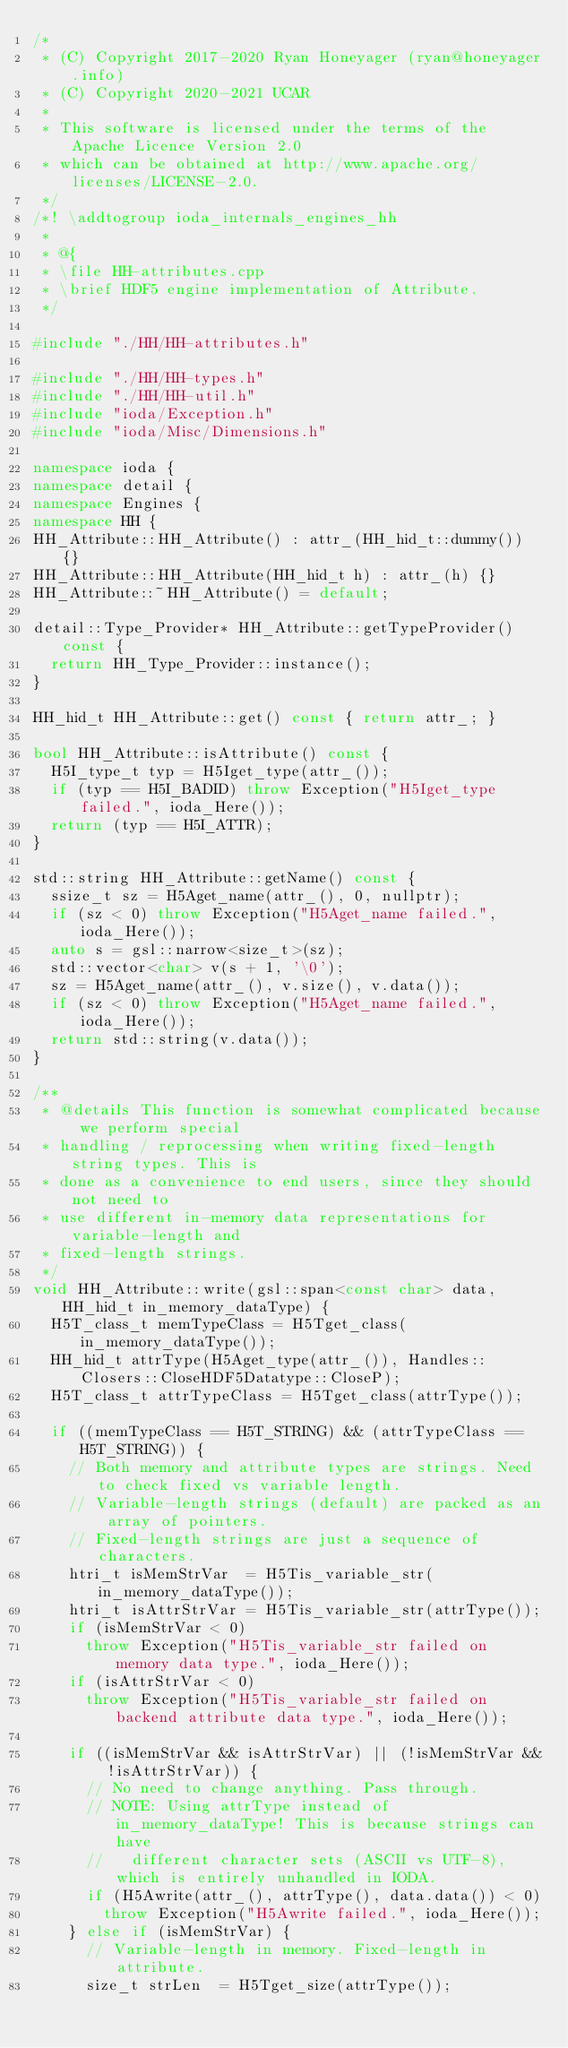<code> <loc_0><loc_0><loc_500><loc_500><_C++_>/*
 * (C) Copyright 2017-2020 Ryan Honeyager (ryan@honeyager.info)
 * (C) Copyright 2020-2021 UCAR
 *
 * This software is licensed under the terms of the Apache Licence Version 2.0
 * which can be obtained at http://www.apache.org/licenses/LICENSE-2.0.
 */
/*! \addtogroup ioda_internals_engines_hh
 *
 * @{
 * \file HH-attributes.cpp
 * \brief HDF5 engine implementation of Attribute.
 */

#include "./HH/HH-attributes.h"

#include "./HH/HH-types.h"
#include "./HH/HH-util.h"
#include "ioda/Exception.h"
#include "ioda/Misc/Dimensions.h"

namespace ioda {
namespace detail {
namespace Engines {
namespace HH {
HH_Attribute::HH_Attribute() : attr_(HH_hid_t::dummy()) {}
HH_Attribute::HH_Attribute(HH_hid_t h) : attr_(h) {}
HH_Attribute::~HH_Attribute() = default;

detail::Type_Provider* HH_Attribute::getTypeProvider() const {
  return HH_Type_Provider::instance();
}

HH_hid_t HH_Attribute::get() const { return attr_; }

bool HH_Attribute::isAttribute() const {
  H5I_type_t typ = H5Iget_type(attr_());
  if (typ == H5I_BADID) throw Exception("H5Iget_type failed.", ioda_Here());
  return (typ == H5I_ATTR);
}

std::string HH_Attribute::getName() const {
  ssize_t sz = H5Aget_name(attr_(), 0, nullptr);
  if (sz < 0) throw Exception("H5Aget_name failed.", ioda_Here());
  auto s = gsl::narrow<size_t>(sz);
  std::vector<char> v(s + 1, '\0');
  sz = H5Aget_name(attr_(), v.size(), v.data());
  if (sz < 0) throw Exception("H5Aget_name failed.", ioda_Here());
  return std::string(v.data());
}

/**
 * @details This function is somewhat complicated because we perform special
 * handling / reprocessing when writing fixed-length string types. This is
 * done as a convenience to end users, since they should not need to
 * use different in-memory data representations for variable-length and
 * fixed-length strings.
 */
void HH_Attribute::write(gsl::span<const char> data, HH_hid_t in_memory_dataType) {
  H5T_class_t memTypeClass = H5Tget_class(in_memory_dataType());
  HH_hid_t attrType(H5Aget_type(attr_()), Handles::Closers::CloseHDF5Datatype::CloseP);
  H5T_class_t attrTypeClass = H5Tget_class(attrType());

  if ((memTypeClass == H5T_STRING) && (attrTypeClass == H5T_STRING)) {
    // Both memory and attribute types are strings. Need to check fixed vs variable length.
    // Variable-length strings (default) are packed as an array of pointers.
    // Fixed-length strings are just a sequence of characters.
    htri_t isMemStrVar  = H5Tis_variable_str(in_memory_dataType());
    htri_t isAttrStrVar = H5Tis_variable_str(attrType());
    if (isMemStrVar < 0)
      throw Exception("H5Tis_variable_str failed on memory data type.", ioda_Here());
    if (isAttrStrVar < 0)
      throw Exception("H5Tis_variable_str failed on backend attribute data type.", ioda_Here());

    if ((isMemStrVar && isAttrStrVar) || (!isMemStrVar && !isAttrStrVar)) {
      // No need to change anything. Pass through.
      // NOTE: Using attrType instead of in_memory_dataType! This is because strings can have
      //   different character sets (ASCII vs UTF-8), which is entirely unhandled in IODA.
      if (H5Awrite(attr_(), attrType(), data.data()) < 0)
        throw Exception("H5Awrite failed.", ioda_Here());
    } else if (isMemStrVar) {
      // Variable-length in memory. Fixed-length in attribute.
      size_t strLen  = H5Tget_size(attrType());</code> 